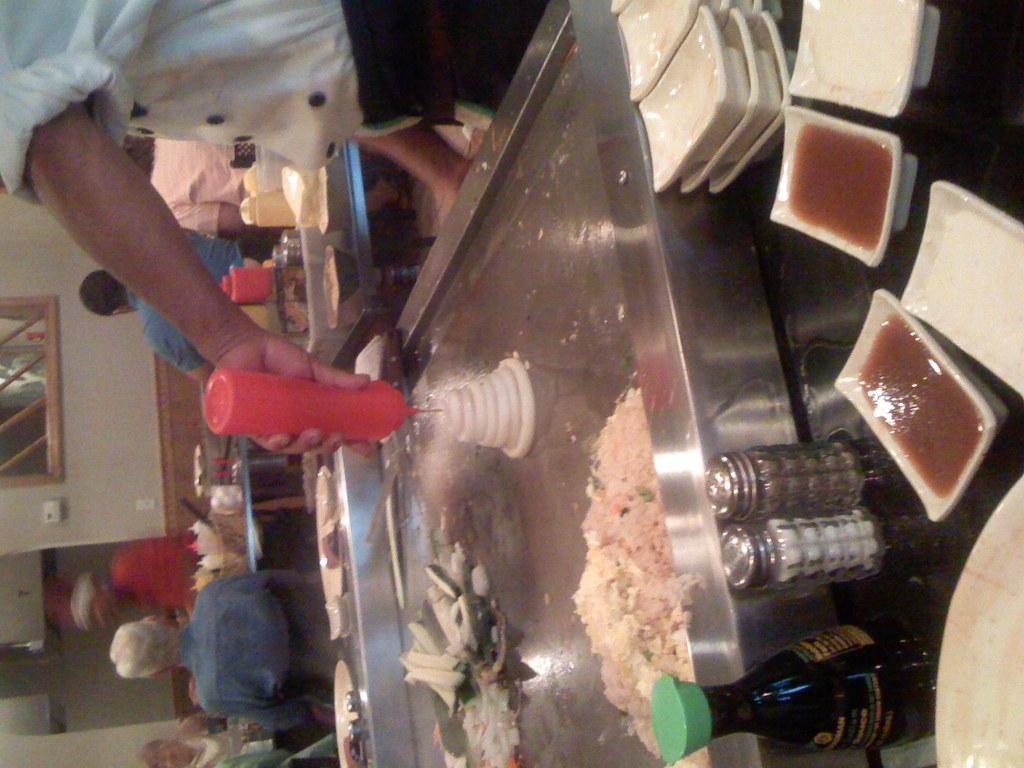Could you give a brief overview of what you see in this image? In the foreground of this image, there are two tins, bottle, platters on a table. There is a man standing at the top holding a bottle and we can also see some food items on the steel surface. In the background, there are few people sitting and standing near tables on which there are few objects and also there is a wall and a window. 